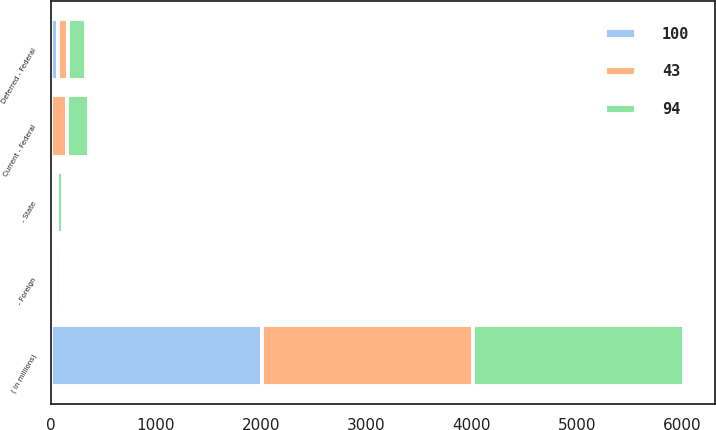<chart> <loc_0><loc_0><loc_500><loc_500><stacked_bar_chart><ecel><fcel>( in millions)<fcel>Current - Federal<fcel>- State<fcel>- Foreign<fcel>Deferred - Federal<nl><fcel>94<fcel>2005<fcel>207<fcel>52<fcel>35<fcel>173<nl><fcel>43<fcel>2004<fcel>153<fcel>34<fcel>29<fcel>90<nl><fcel>100<fcel>2003<fcel>5<fcel>28<fcel>25<fcel>73<nl></chart> 